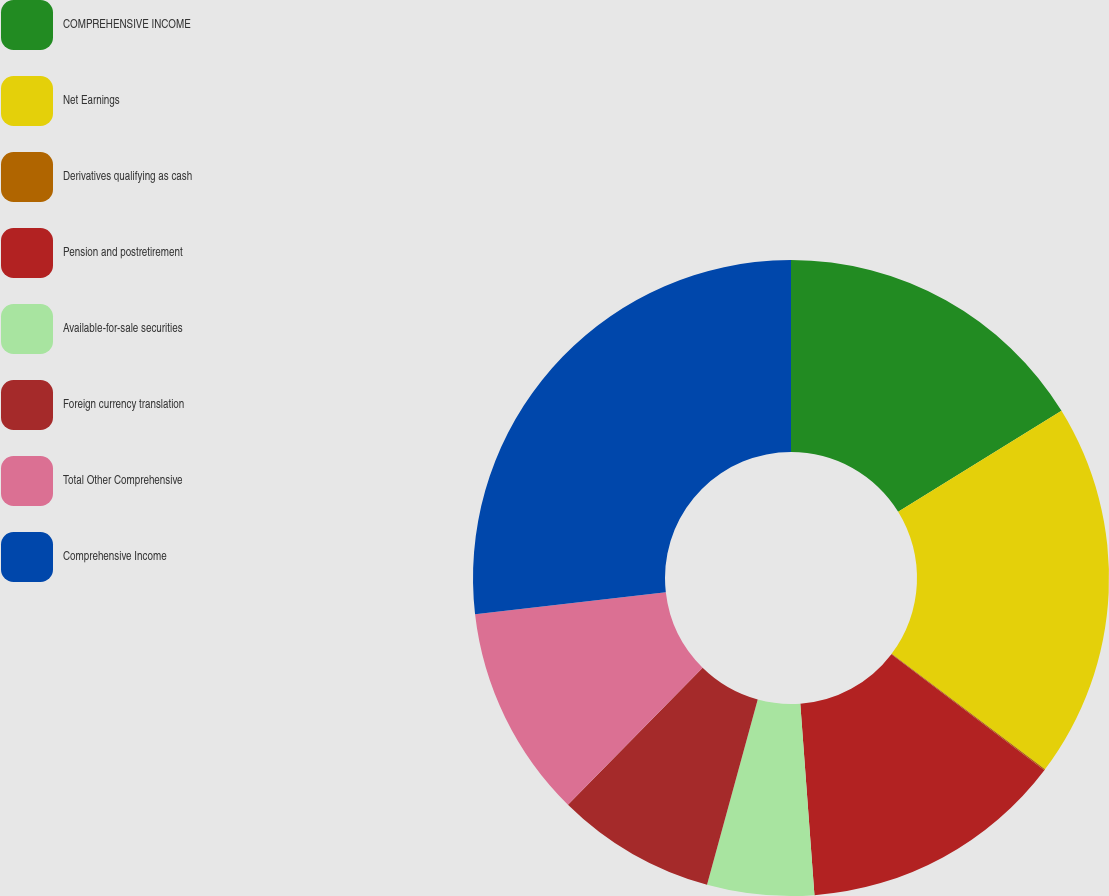<chart> <loc_0><loc_0><loc_500><loc_500><pie_chart><fcel>COMPREHENSIVE INCOME<fcel>Net Earnings<fcel>Derivatives qualifying as cash<fcel>Pension and postretirement<fcel>Available-for-sale securities<fcel>Foreign currency translation<fcel>Total Other Comprehensive<fcel>Comprehensive Income<nl><fcel>16.19%<fcel>19.09%<fcel>0.05%<fcel>13.5%<fcel>5.43%<fcel>8.12%<fcel>10.81%<fcel>26.82%<nl></chart> 